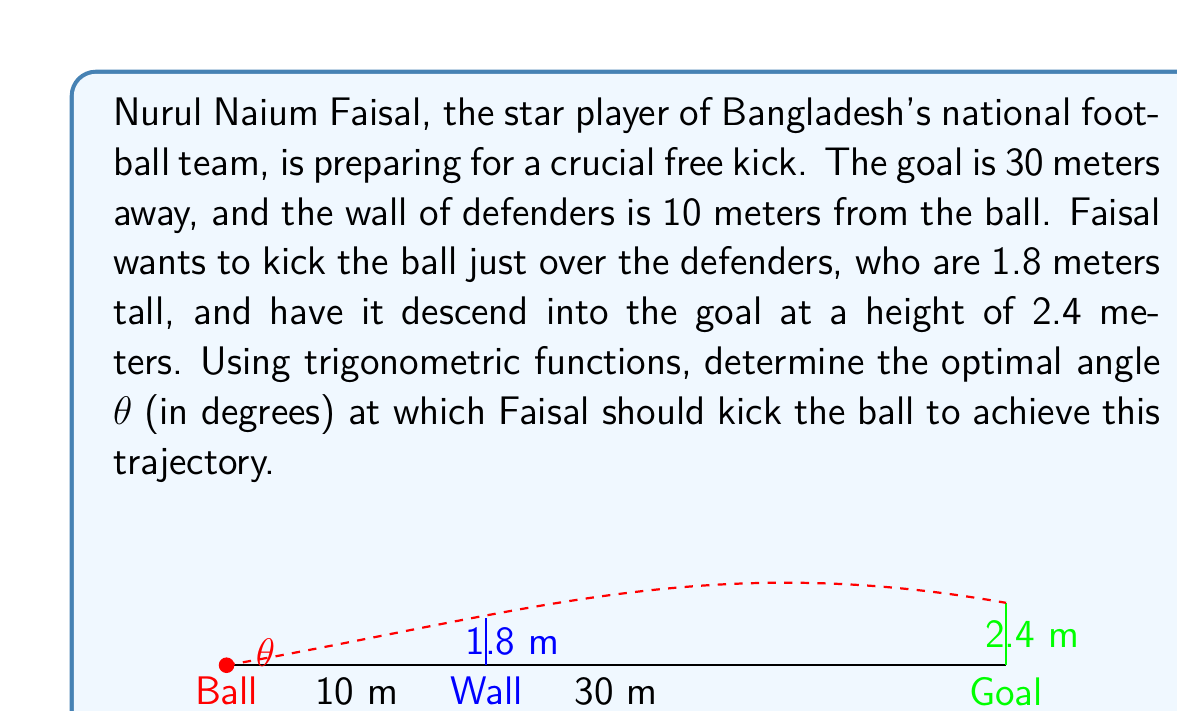Can you solve this math problem? To solve this problem, we'll use the principles of projectile motion and trigonometry. Let's approach this step-by-step:

1) First, we need to set up our coordinate system. Let the ball's initial position be (0,0) and the goal be at (30, 2.4).

2) The trajectory of the ball can be described by a quadratic function:

   $$y = ax^2 + bx$$

   Where $a$ is related to the angle of the kick and the initial velocity, and $b = \tan(\theta)$.

3) We know two points on this trajectory:
   - The ball must pass just over the wall: (10, 1.8)
   - The ball must end at the goal: (30, 2.4)

4) Substituting these points into our equation:

   $$1.8 = 100a + 10b$$
   $$2.4 = 900a + 30b$$

5) Solving this system of equations:
   
   Multiply the first equation by 3 and subtract from the second:
   
   $$5.4 = 300a + 30b$$
   $$2.4 = 900a + 30b$$
   $$3.0 = -600a$$
   
   $$a = -\frac{1}{200}$$

6) Substitute this back into either equation to find $b$:

   $$1.8 = 100(-\frac{1}{200}) + 10b$$
   $$1.8 = -0.5 + 10b$$
   $$2.3 = 10b$$
   $$b = 0.23$$

7) Remember that $b = \tan(\theta)$, so:

   $$\theta = \arctan(0.23)$$

8) Convert to degrees:

   $$\theta = \arctan(0.23) * \frac{180}{\pi} \approx 12.95°$$

Therefore, the optimal angle for Faisal to kick the ball is approximately 12.95 degrees.
Answer: $\theta \approx 12.95°$ 